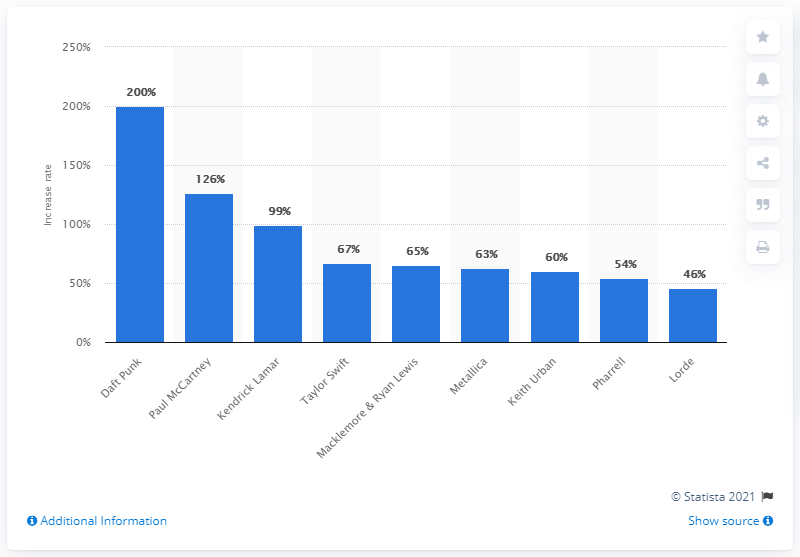List a handful of essential elements in this visual. The former Beatles member, Paul McCartney, experienced a 126 percent increase in the number of people streaming his music on Spotify. 